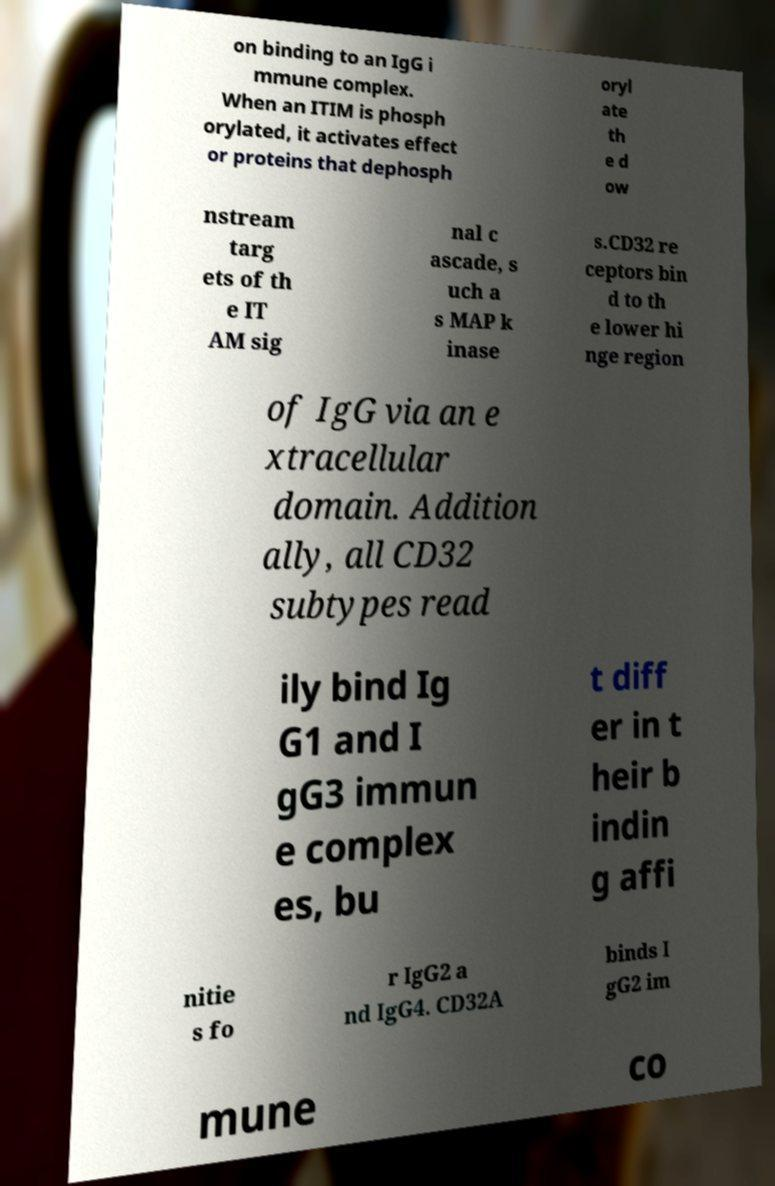For documentation purposes, I need the text within this image transcribed. Could you provide that? on binding to an IgG i mmune complex. When an ITIM is phosph orylated, it activates effect or proteins that dephosph oryl ate th e d ow nstream targ ets of th e IT AM sig nal c ascade, s uch a s MAP k inase s.CD32 re ceptors bin d to th e lower hi nge region of IgG via an e xtracellular domain. Addition ally, all CD32 subtypes read ily bind Ig G1 and I gG3 immun e complex es, bu t diff er in t heir b indin g affi nitie s fo r IgG2 a nd IgG4. CD32A binds I gG2 im mune co 